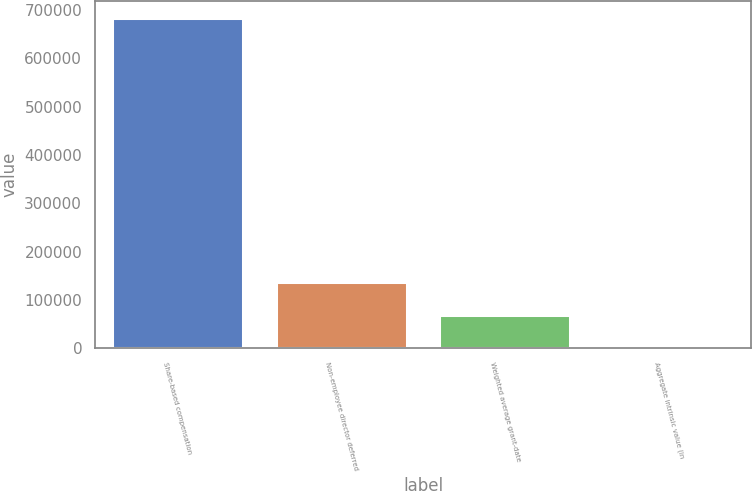Convert chart to OTSL. <chart><loc_0><loc_0><loc_500><loc_500><bar_chart><fcel>Share-based compensation<fcel>Non-employee director deferred<fcel>Weighted average grant-date<fcel>Aggregate intrinsic value (in<nl><fcel>684000<fcel>136800<fcel>68400.4<fcel>0.4<nl></chart> 